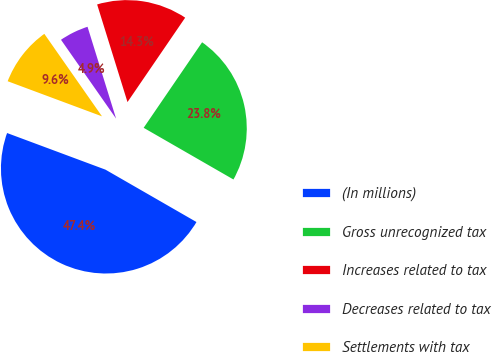Convert chart. <chart><loc_0><loc_0><loc_500><loc_500><pie_chart><fcel>(In millions)<fcel>Gross unrecognized tax<fcel>Increases related to tax<fcel>Decreases related to tax<fcel>Settlements with tax<nl><fcel>47.36%<fcel>23.77%<fcel>14.34%<fcel>4.91%<fcel>9.62%<nl></chart> 